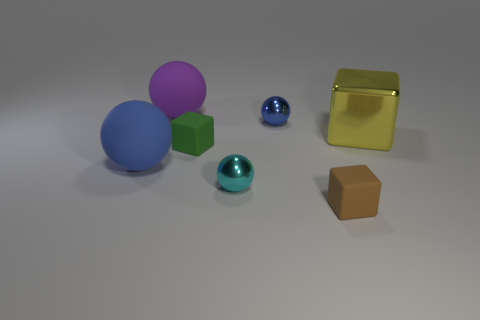Do the green matte object and the tiny brown rubber object have the same shape? Yes, both the green matte object and the tiny brown rubber object have a cubic shape, featuring six faces, twelve edges, and eight vertices. 